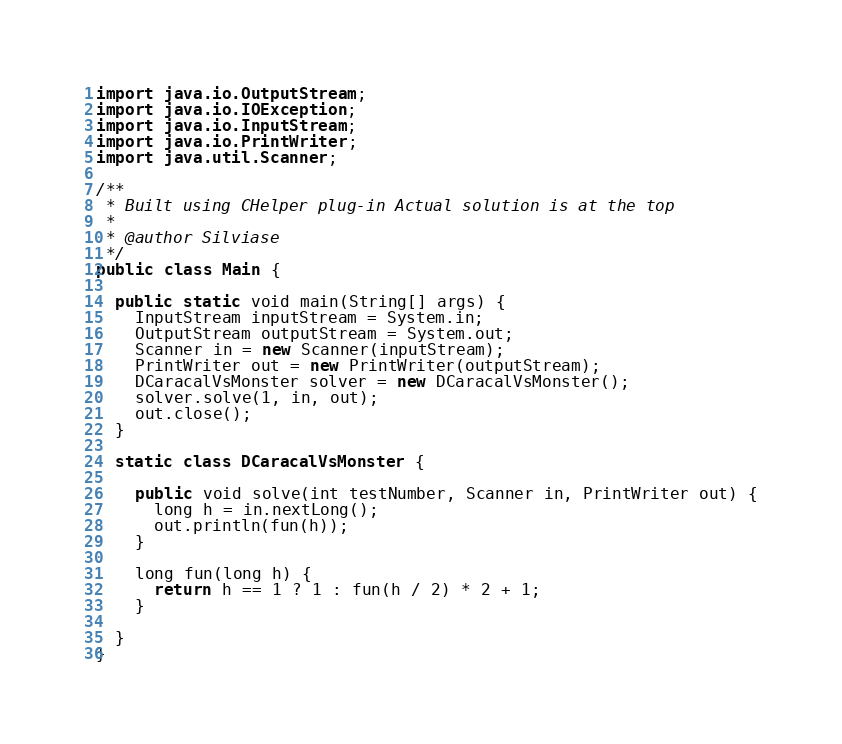<code> <loc_0><loc_0><loc_500><loc_500><_Java_>import java.io.OutputStream;
import java.io.IOException;
import java.io.InputStream;
import java.io.PrintWriter;
import java.util.Scanner;

/**
 * Built using CHelper plug-in Actual solution is at the top
 *
 * @author Silviase
 */
public class Main {

  public static void main(String[] args) {
    InputStream inputStream = System.in;
    OutputStream outputStream = System.out;
    Scanner in = new Scanner(inputStream);
    PrintWriter out = new PrintWriter(outputStream);
    DCaracalVsMonster solver = new DCaracalVsMonster();
    solver.solve(1, in, out);
    out.close();
  }

  static class DCaracalVsMonster {

    public void solve(int testNumber, Scanner in, PrintWriter out) {
      long h = in.nextLong();
      out.println(fun(h));
    }

    long fun(long h) {
      return h == 1 ? 1 : fun(h / 2) * 2 + 1;
    }

  }
}

</code> 